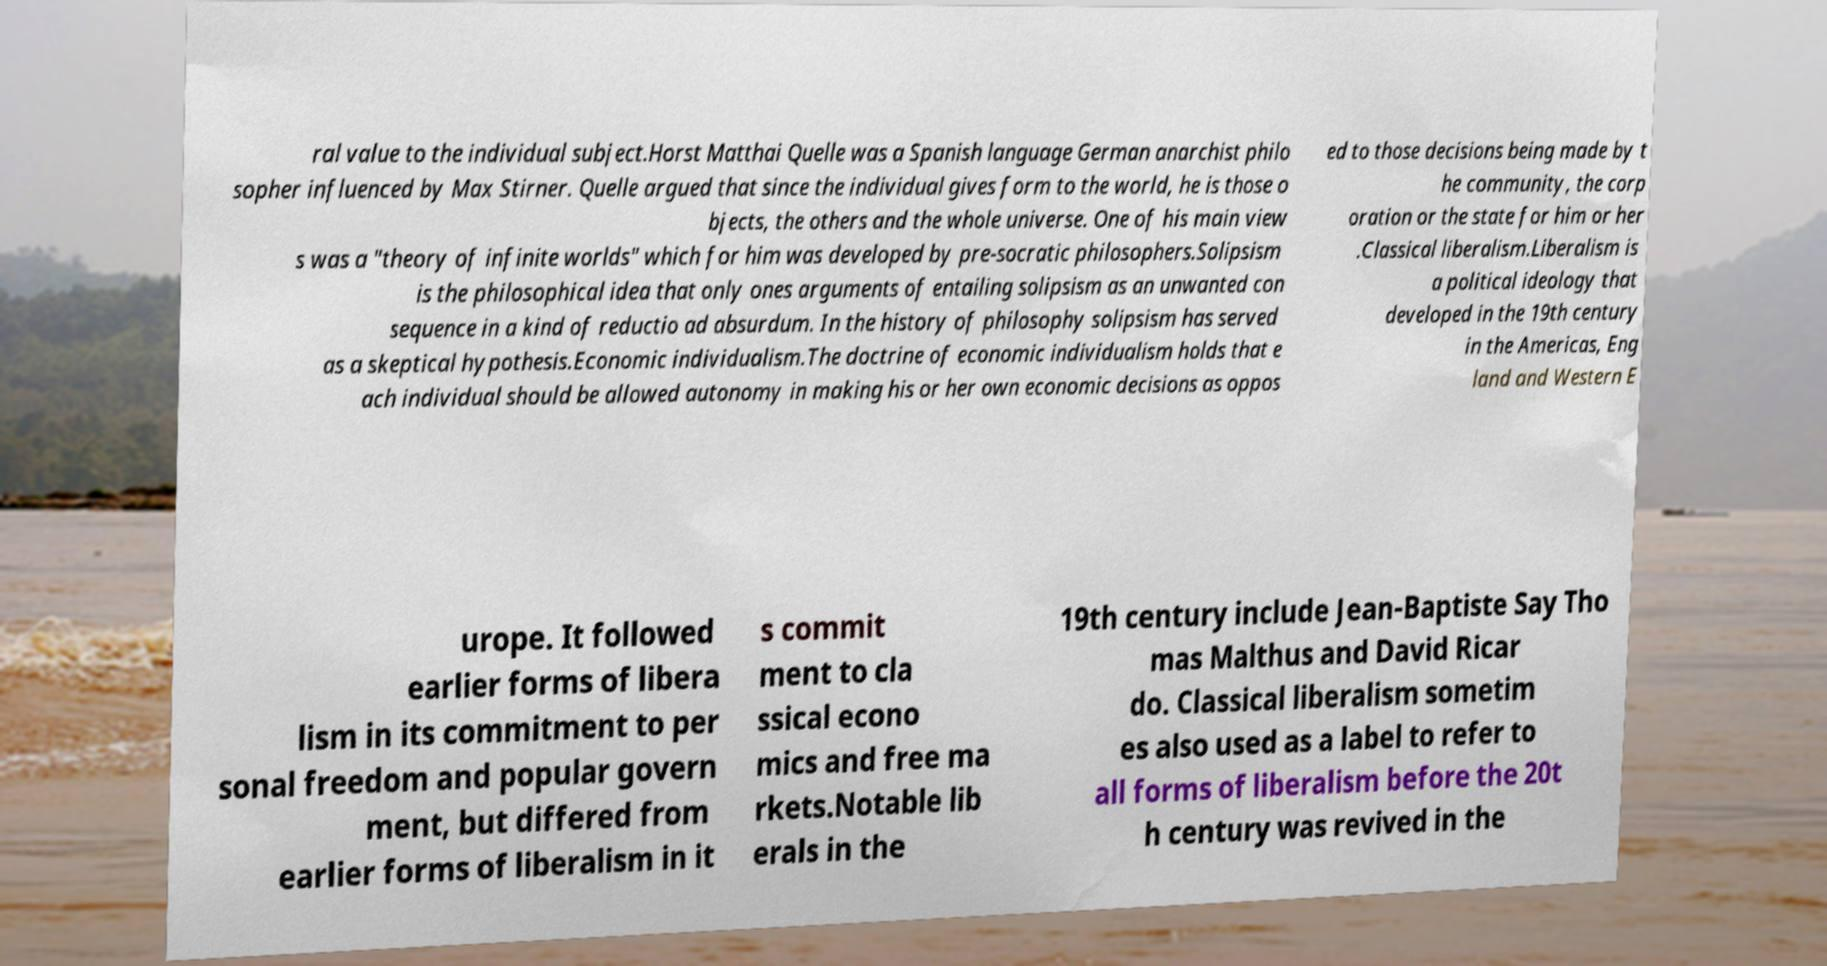What messages or text are displayed in this image? I need them in a readable, typed format. ral value to the individual subject.Horst Matthai Quelle was a Spanish language German anarchist philo sopher influenced by Max Stirner. Quelle argued that since the individual gives form to the world, he is those o bjects, the others and the whole universe. One of his main view s was a "theory of infinite worlds" which for him was developed by pre-socratic philosophers.Solipsism is the philosophical idea that only ones arguments of entailing solipsism as an unwanted con sequence in a kind of reductio ad absurdum. In the history of philosophy solipsism has served as a skeptical hypothesis.Economic individualism.The doctrine of economic individualism holds that e ach individual should be allowed autonomy in making his or her own economic decisions as oppos ed to those decisions being made by t he community, the corp oration or the state for him or her .Classical liberalism.Liberalism is a political ideology that developed in the 19th century in the Americas, Eng land and Western E urope. It followed earlier forms of libera lism in its commitment to per sonal freedom and popular govern ment, but differed from earlier forms of liberalism in it s commit ment to cla ssical econo mics and free ma rkets.Notable lib erals in the 19th century include Jean-Baptiste Say Tho mas Malthus and David Ricar do. Classical liberalism sometim es also used as a label to refer to all forms of liberalism before the 20t h century was revived in the 